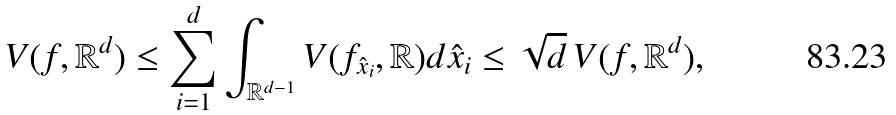<formula> <loc_0><loc_0><loc_500><loc_500>V ( f , \mathbb { R } ^ { d } ) \leq \sum _ { i = 1 } ^ { d } \int _ { \mathbb { R } ^ { d - 1 } } V ( f _ { \hat { x } _ { i } } , \mathbb { R } ) d \hat { x } _ { i } \leq \sqrt { d } \, V ( f , \mathbb { R } ^ { d } ) ,</formula> 